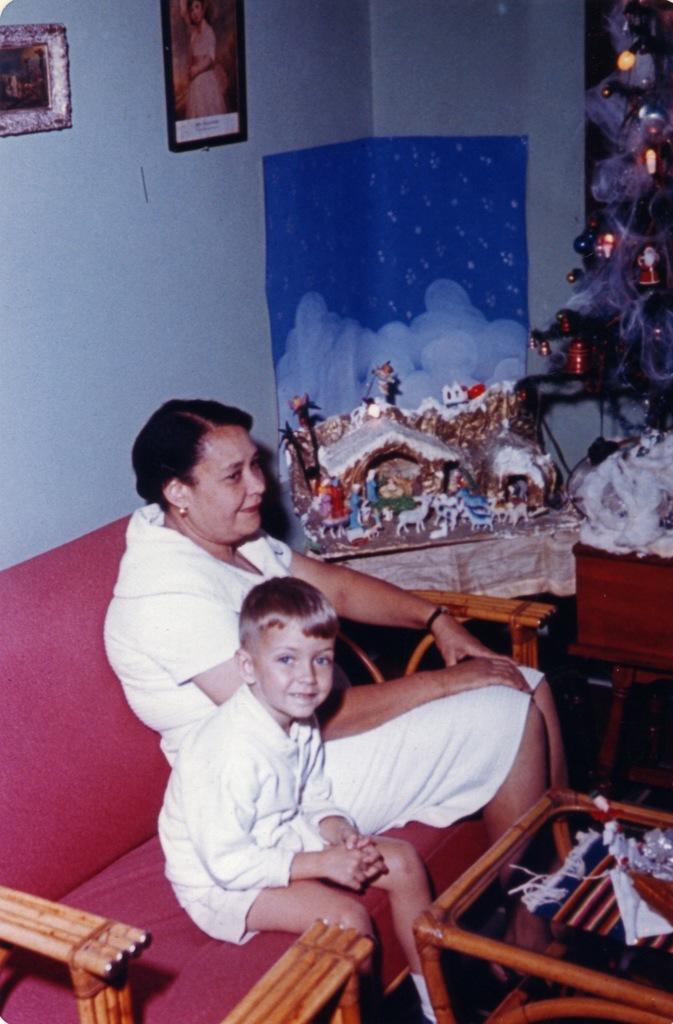In one or two sentences, can you explain what this image depicts? In this image I can see a woman and a boy sitting on the couch. This is a tea point where some objects are placed. This looks like a Christmas toy,and at the right corner of the image I can see a Christmas tree. There are photo frames attached to the wall. 